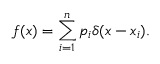<formula> <loc_0><loc_0><loc_500><loc_500>f ( x ) = \sum _ { i = 1 } ^ { n } p _ { i } \delta ( x - x _ { i } ) .</formula> 